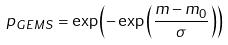Convert formula to latex. <formula><loc_0><loc_0><loc_500><loc_500>p _ { G E M S } = \exp \left ( - \exp \left ( \frac { m - m _ { 0 } } { \sigma } \right ) \right )</formula> 